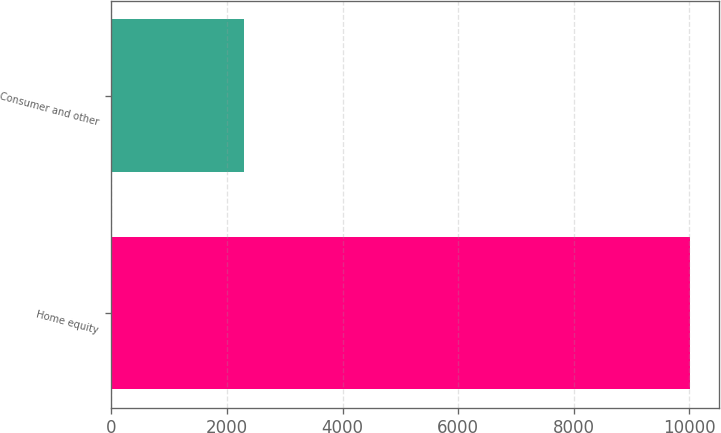<chart> <loc_0><loc_0><loc_500><loc_500><bar_chart><fcel>Home equity<fcel>Consumer and other<nl><fcel>10017.2<fcel>2298.6<nl></chart> 